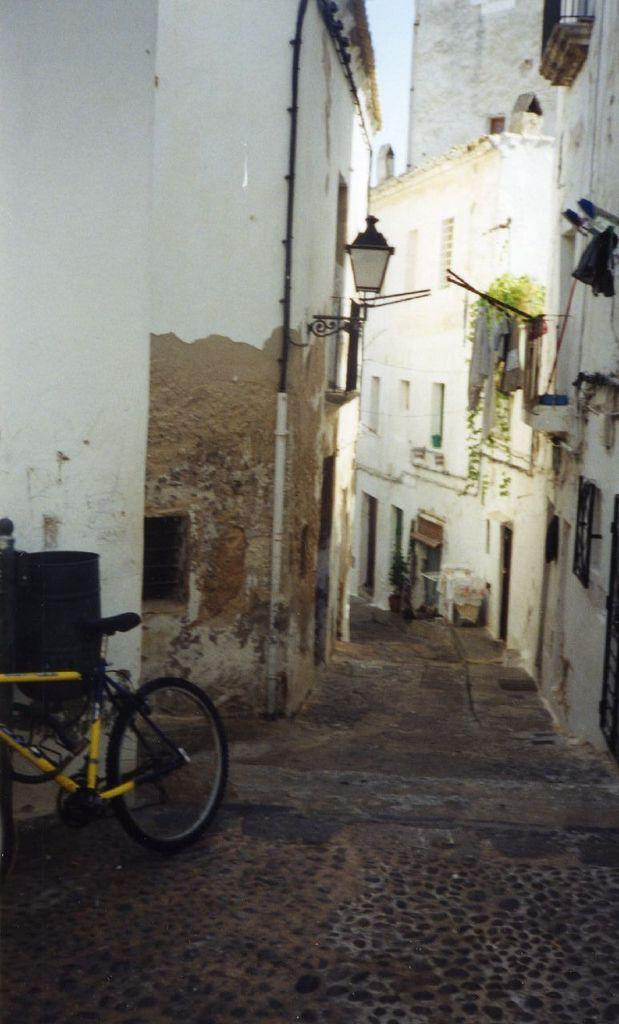What can be seen in the image that people use for transportation? There is a bicycle in the image that people can use for transportation. What type of lighting is present in the image? There is a lamp in the image that provides lighting. What type of vegetation can be seen in the image? There are house plants in the image. What type of structures are visible in the image? There are buildings in the image. What other objects can be seen in the image? There are some objects in the image, but their specific details are not mentioned in the facts. What can be seen in the background of the image? The sky is visible in the background of the image. Can you tell me the credit score of the person riding the bicycle in the image? There is no information about the credit score of the person riding the bicycle in the image, as it is not relevant to the image's content. What type of baseball equipment can be seen in the image? There is no baseball equipment present in the image. 